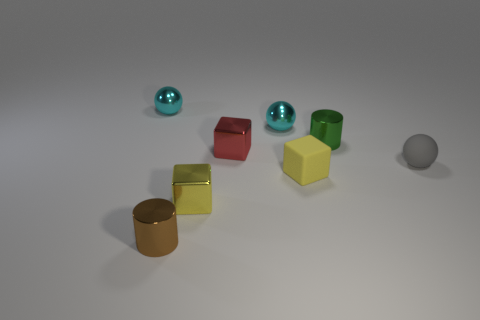Subtract all tiny matte balls. How many balls are left? 2 Subtract 0 purple cylinders. How many objects are left? 8 Subtract all cylinders. How many objects are left? 6 Subtract 1 balls. How many balls are left? 2 Subtract all green cylinders. Subtract all yellow spheres. How many cylinders are left? 1 Subtract all cyan cubes. How many brown cylinders are left? 1 Subtract all red metal things. Subtract all large blue cylinders. How many objects are left? 7 Add 7 gray balls. How many gray balls are left? 8 Add 5 tiny red objects. How many tiny red objects exist? 6 Add 2 green cylinders. How many objects exist? 10 